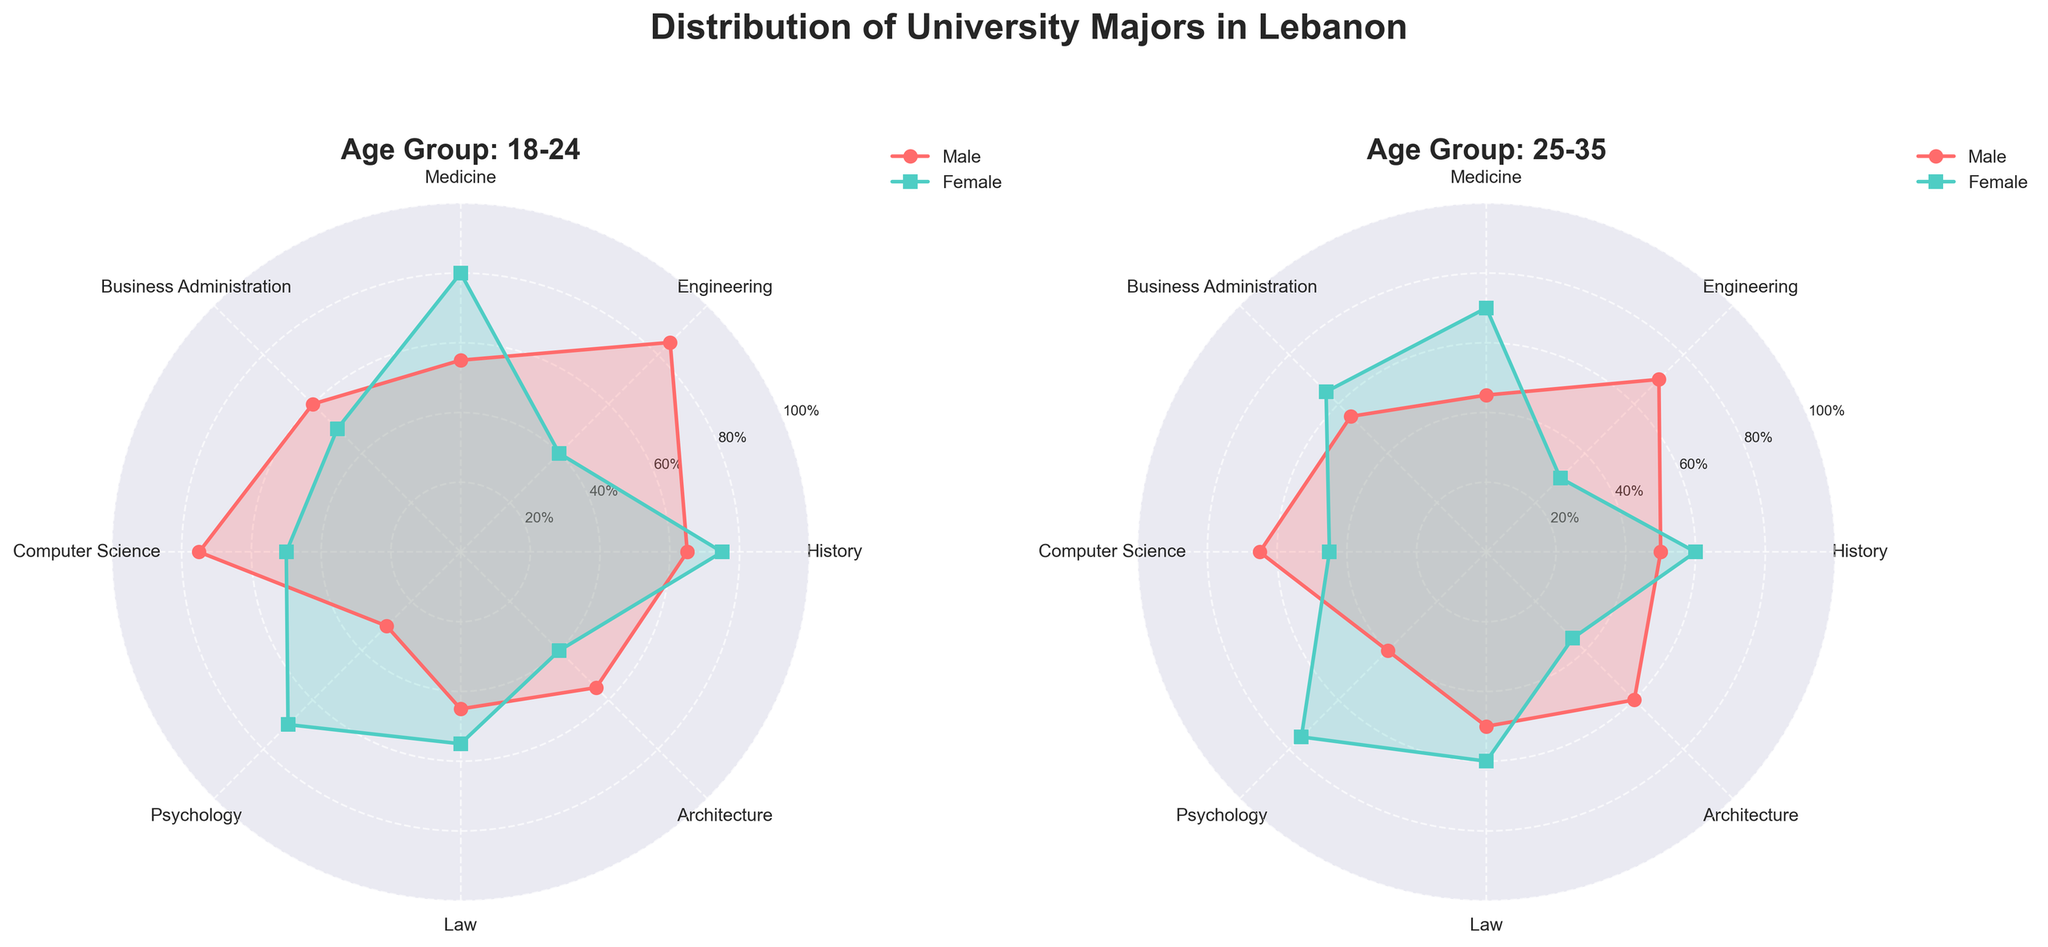what are the two age groups examined in the radar charts? The radar charts have titles that indicate the two different age groups being examined. One chart is titled "Age Group: 18-24" and the other is titled "Age Group: 25-35."
Answer: 18-24 and 25-35 Which major is most popular among 18-24-year-old males? By observing the chart for the 18-24 age group, we can see that the major with the highest value on the radial axis for males is Engineering. Its popularity is 85, the highest among all majors for 18-24-year-old males.
Answer: Engineering In which age group is Psychology more popular among females? By comparing the two charts, we see that in the 18-24 age group, the popularity of Psychology among females is 70,  while in the 25-35 age group, the popularity is 75. Thus, Psychology is more popular among females in the 25-35 age group.
Answer: 25-35 What is the popularity difference of Medicine between 18-24-year-old males and females? In the radar chart for the 18-24 age group, we find the popularity values for Medicine: 55 for males and 80 for females. The difference is 80 - 55 = 25.
Answer: 25 Which major shows the most gender disparity in the 18-24 age group? In the radar chart for the 18-24 age group, we examine each major and compare the popularity values between males and females. Engineering shows the largest gap with 85 for males and 40 for females, a disparity of 45.
Answer: Engineering How does the popularity of History among females change from the 18-24 age group to the 25-35 age group? In the radar chart for females, we see that the popularity of History is 75 in the 18-24 age group and decreases to 60 in the 25-35 age group.
Answer: Decreases For the 25-35 age group, which major has an equal or almost equal popularity among males and females? In the radar chart for the 25-35 age group, we observe that History (50 males, 60 females) and Law (50 males, 60 females) are close in popularity, but none are equal.
Answer: None Is Computer Science more popular among males or females in the 25-35 age group? In the radar chart for the 25-35 age group, we see that the popularity of Computer Science is 65 among males and 45 among females. Therefore, it is more popular among males.
Answer: Males What major is least popular among 25-35-year-old males? In the radar chart for the 25-35 age group, we see that the major with the lowest popularity for males is Psychology, with a value of 40.
Answer: Psychology 